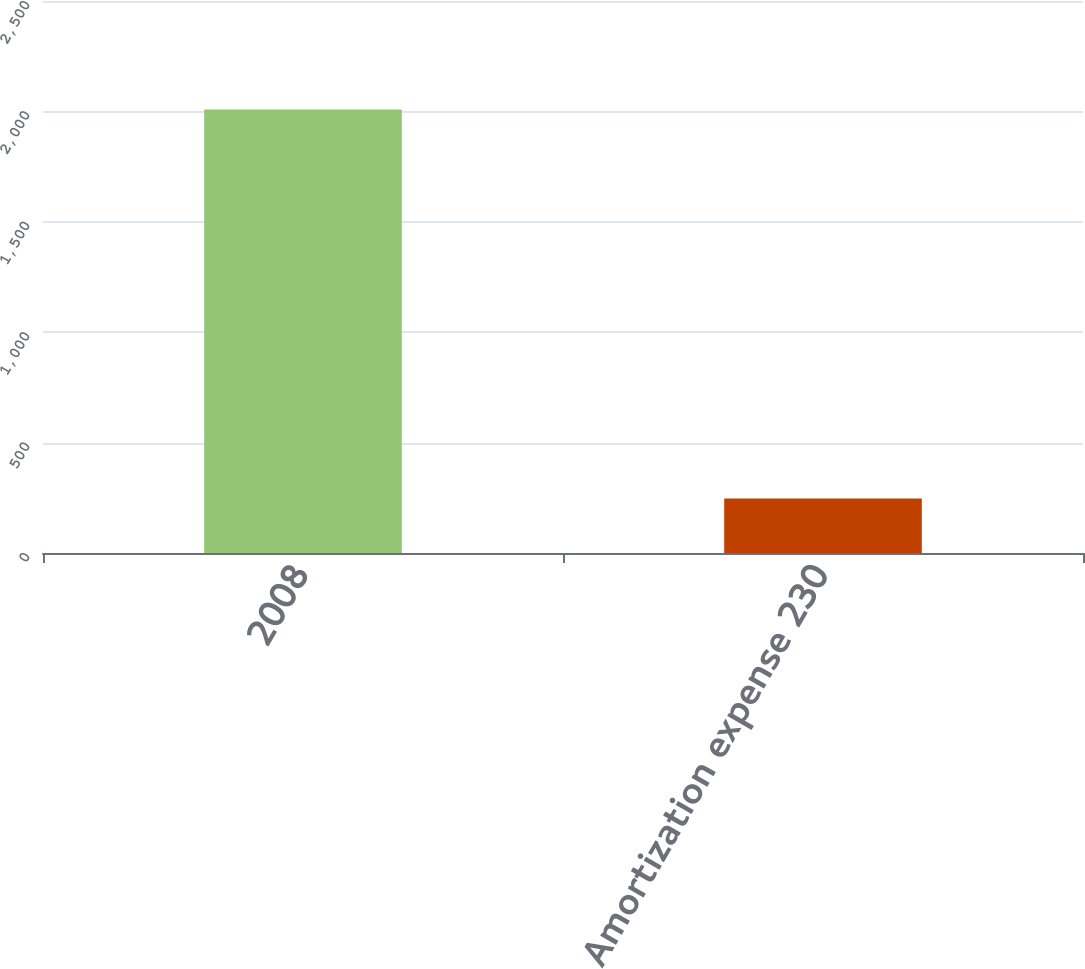<chart> <loc_0><loc_0><loc_500><loc_500><bar_chart><fcel>2008<fcel>Amortization expense 230<nl><fcel>2009<fcel>247<nl></chart> 